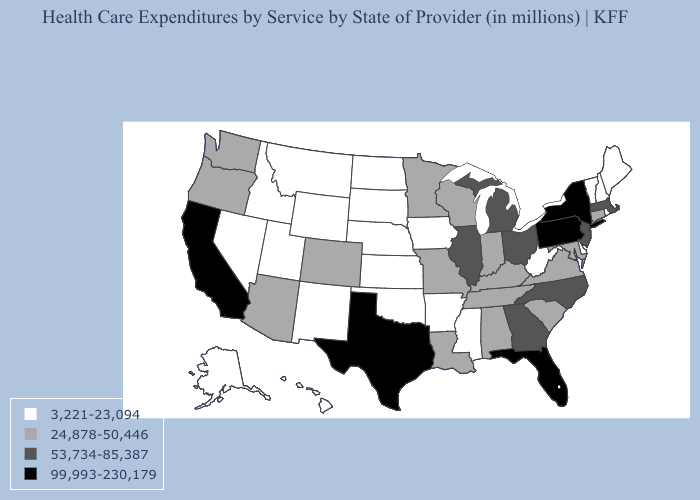What is the value of Oregon?
Short answer required. 24,878-50,446. Name the states that have a value in the range 53,734-85,387?
Quick response, please. Georgia, Illinois, Massachusetts, Michigan, New Jersey, North Carolina, Ohio. Name the states that have a value in the range 3,221-23,094?
Give a very brief answer. Alaska, Arkansas, Delaware, Hawaii, Idaho, Iowa, Kansas, Maine, Mississippi, Montana, Nebraska, Nevada, New Hampshire, New Mexico, North Dakota, Oklahoma, Rhode Island, South Dakota, Utah, Vermont, West Virginia, Wyoming. Name the states that have a value in the range 24,878-50,446?
Quick response, please. Alabama, Arizona, Colorado, Connecticut, Indiana, Kentucky, Louisiana, Maryland, Minnesota, Missouri, Oregon, South Carolina, Tennessee, Virginia, Washington, Wisconsin. What is the value of Illinois?
Concise answer only. 53,734-85,387. Among the states that border Utah , which have the lowest value?
Write a very short answer. Idaho, Nevada, New Mexico, Wyoming. Name the states that have a value in the range 99,993-230,179?
Be succinct. California, Florida, New York, Pennsylvania, Texas. Name the states that have a value in the range 24,878-50,446?
Write a very short answer. Alabama, Arizona, Colorado, Connecticut, Indiana, Kentucky, Louisiana, Maryland, Minnesota, Missouri, Oregon, South Carolina, Tennessee, Virginia, Washington, Wisconsin. What is the value of Alaska?
Short answer required. 3,221-23,094. Does Idaho have the lowest value in the USA?
Write a very short answer. Yes. What is the lowest value in states that border Idaho?
Answer briefly. 3,221-23,094. How many symbols are there in the legend?
Answer briefly. 4. What is the value of New Mexico?
Write a very short answer. 3,221-23,094. What is the lowest value in the USA?
Quick response, please. 3,221-23,094. Does Texas have the highest value in the USA?
Short answer required. Yes. 